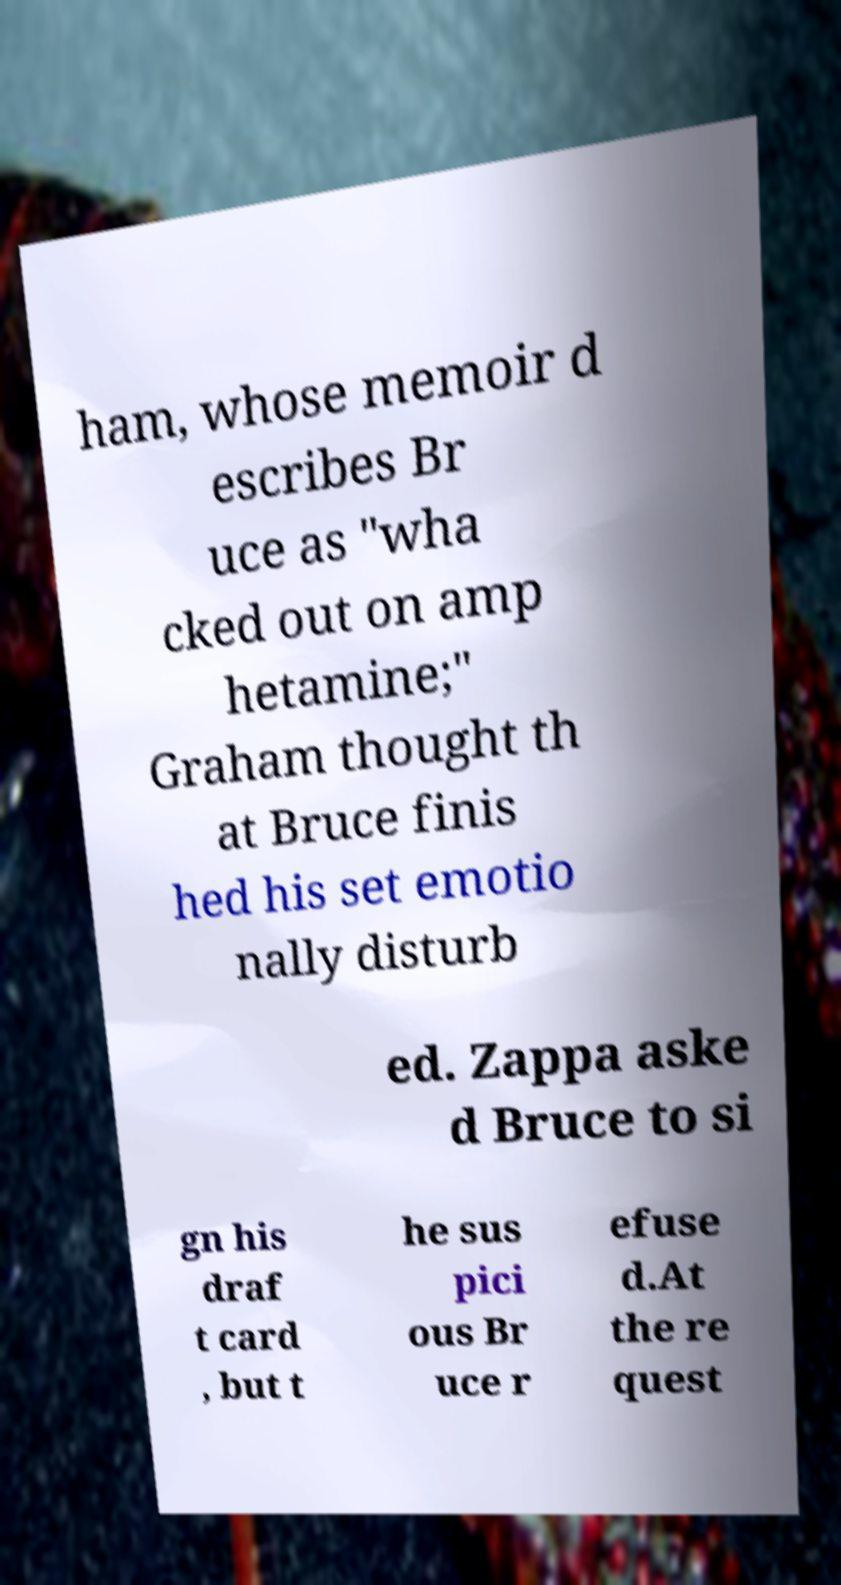For documentation purposes, I need the text within this image transcribed. Could you provide that? ham, whose memoir d escribes Br uce as "wha cked out on amp hetamine;" Graham thought th at Bruce finis hed his set emotio nally disturb ed. Zappa aske d Bruce to si gn his draf t card , but t he sus pici ous Br uce r efuse d.At the re quest 